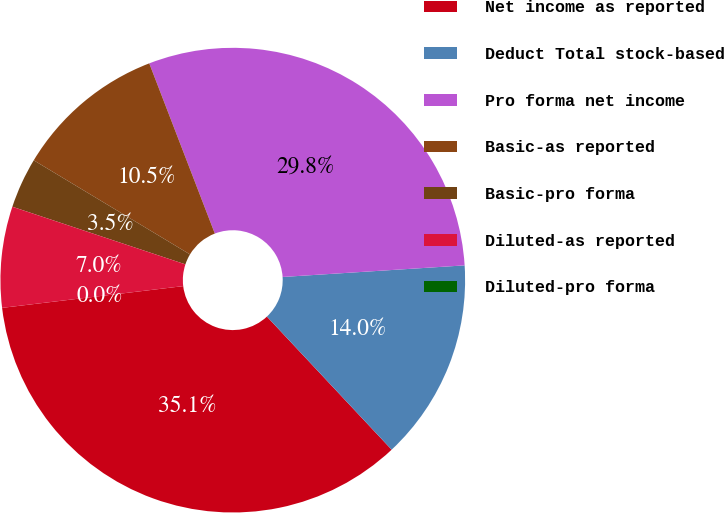Convert chart. <chart><loc_0><loc_0><loc_500><loc_500><pie_chart><fcel>Net income as reported<fcel>Deduct Total stock-based<fcel>Pro forma net income<fcel>Basic-as reported<fcel>Basic-pro forma<fcel>Diluted-as reported<fcel>Diluted-pro forma<nl><fcel>35.08%<fcel>14.03%<fcel>29.84%<fcel>10.52%<fcel>3.51%<fcel>7.02%<fcel>0.0%<nl></chart> 